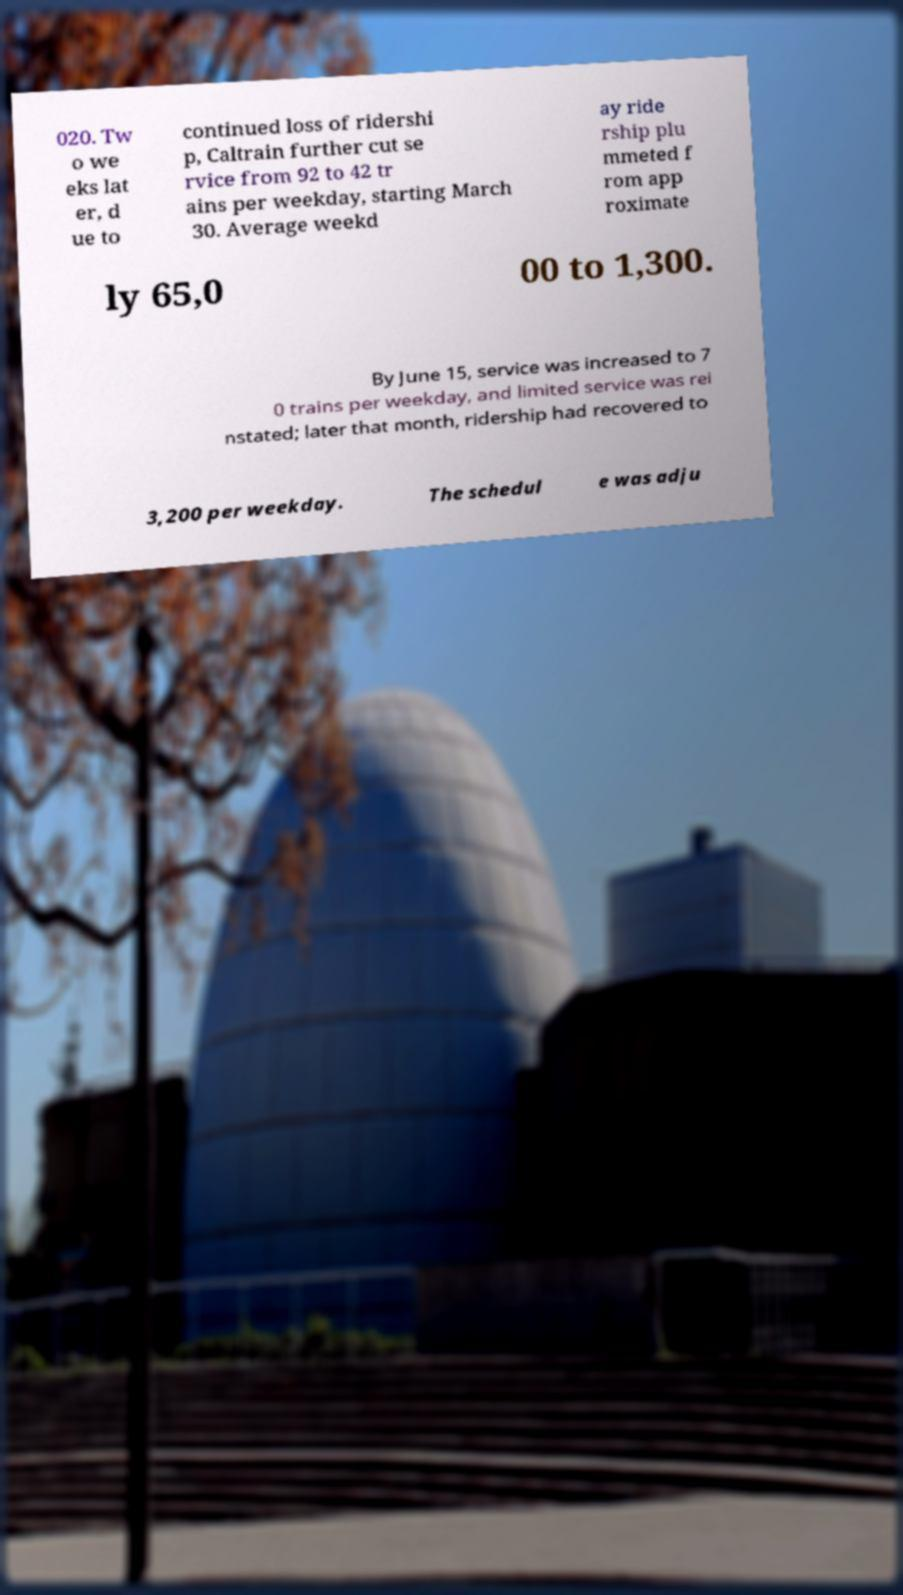For documentation purposes, I need the text within this image transcribed. Could you provide that? 020. Tw o we eks lat er, d ue to continued loss of ridershi p, Caltrain further cut se rvice from 92 to 42 tr ains per weekday, starting March 30. Average weekd ay ride rship plu mmeted f rom app roximate ly 65,0 00 to 1,300. By June 15, service was increased to 7 0 trains per weekday, and limited service was rei nstated; later that month, ridership had recovered to 3,200 per weekday. The schedul e was adju 